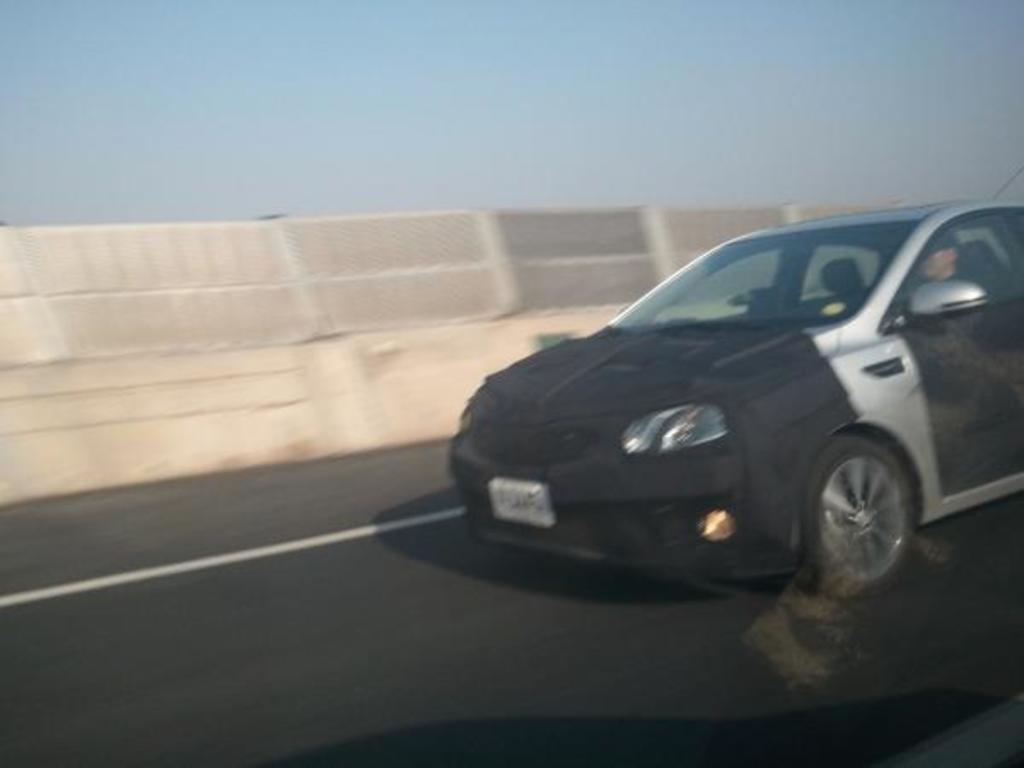Please provide a concise description of this image. In this picture we can observe a car on the road. The car is in black color. In the background we can observe a wall and a sky. 